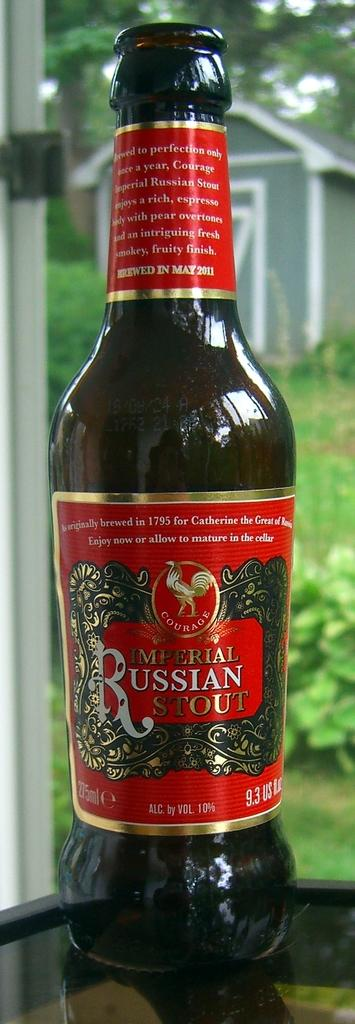<image>
Render a clear and concise summary of the photo. A brown bottle with a red label and in white and gold letters says Imperial Russian Stout. 